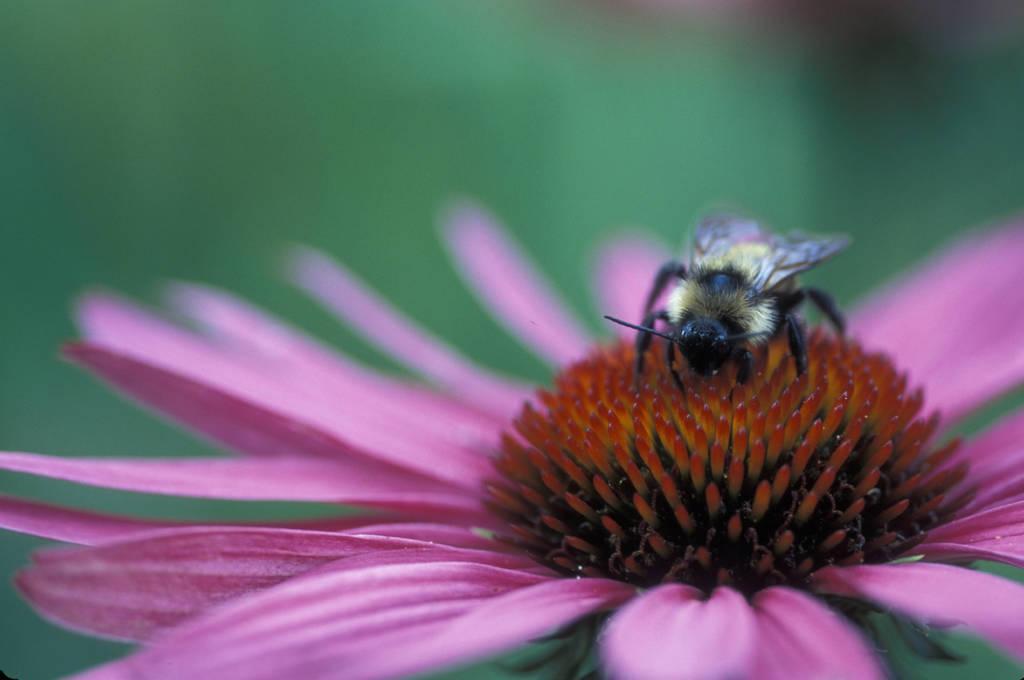In one or two sentences, can you explain what this image depicts? There is a bee on a pink flower. 